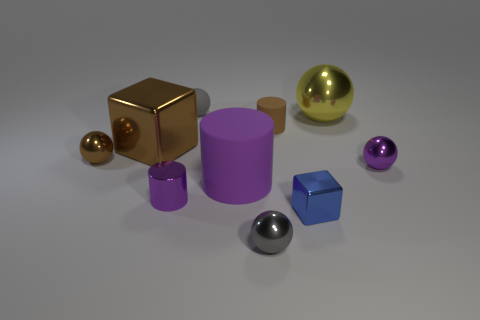Subtract 2 balls. How many balls are left? 3 Subtract all big balls. How many balls are left? 4 Subtract all purple spheres. How many spheres are left? 4 Subtract all cyan balls. Subtract all green cylinders. How many balls are left? 5 Subtract all cylinders. How many objects are left? 7 Subtract 0 yellow cylinders. How many objects are left? 10 Subtract all blue blocks. Subtract all shiny balls. How many objects are left? 5 Add 4 purple matte things. How many purple matte things are left? 5 Add 9 big brown cubes. How many big brown cubes exist? 10 